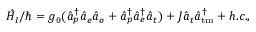Convert formula to latex. <formula><loc_0><loc_0><loc_500><loc_500>\hat { H } _ { I } / \hbar { = } g _ { 0 } ( \hat { a } _ { p } ^ { \dagger } \hat { a } _ { e } \hat { a } _ { o } + \hat { a } _ { p } ^ { \dagger } \hat { a } _ { e } ^ { \dagger } \hat { a } _ { t } ) + J \hat { a } _ { t } \hat { a } _ { t m } ^ { \dagger } + h . c . ,</formula> 